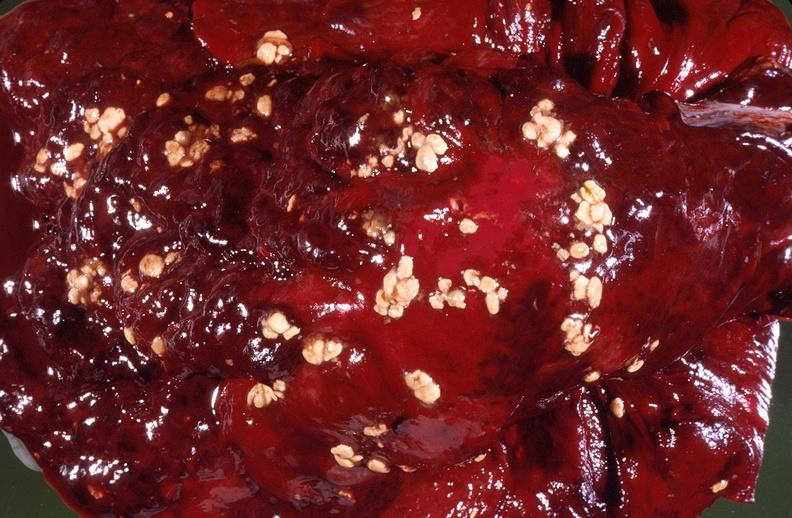what does this image show?
Answer the question using a single word or phrase. Pleural cavity 